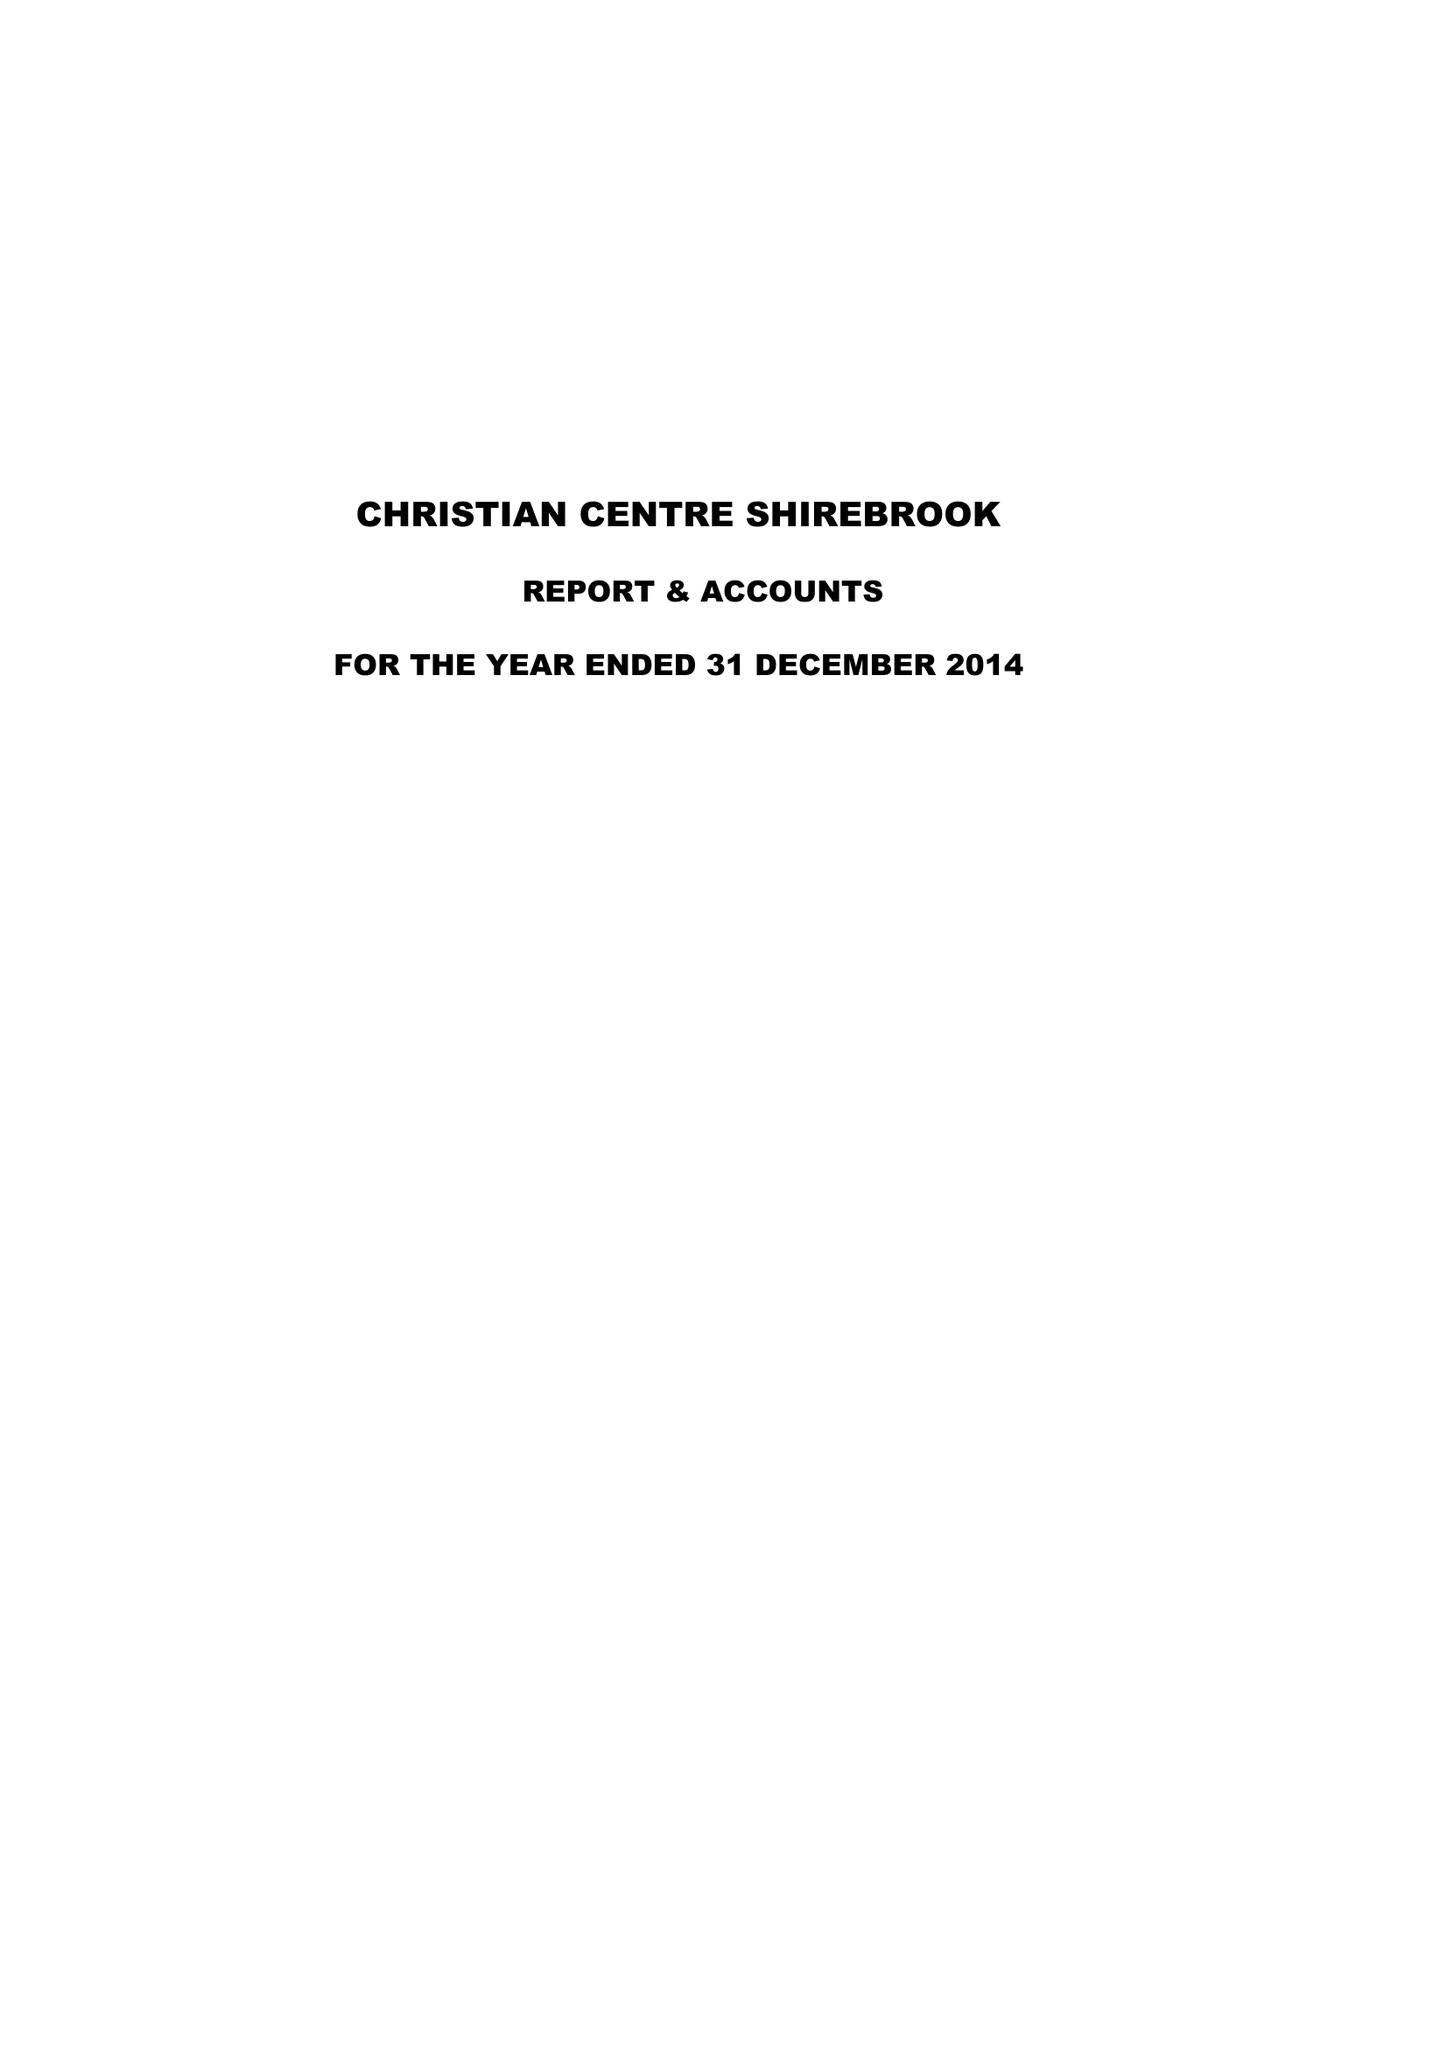What is the value for the address__post_town?
Answer the question using a single word or phrase. MANSFIELD 